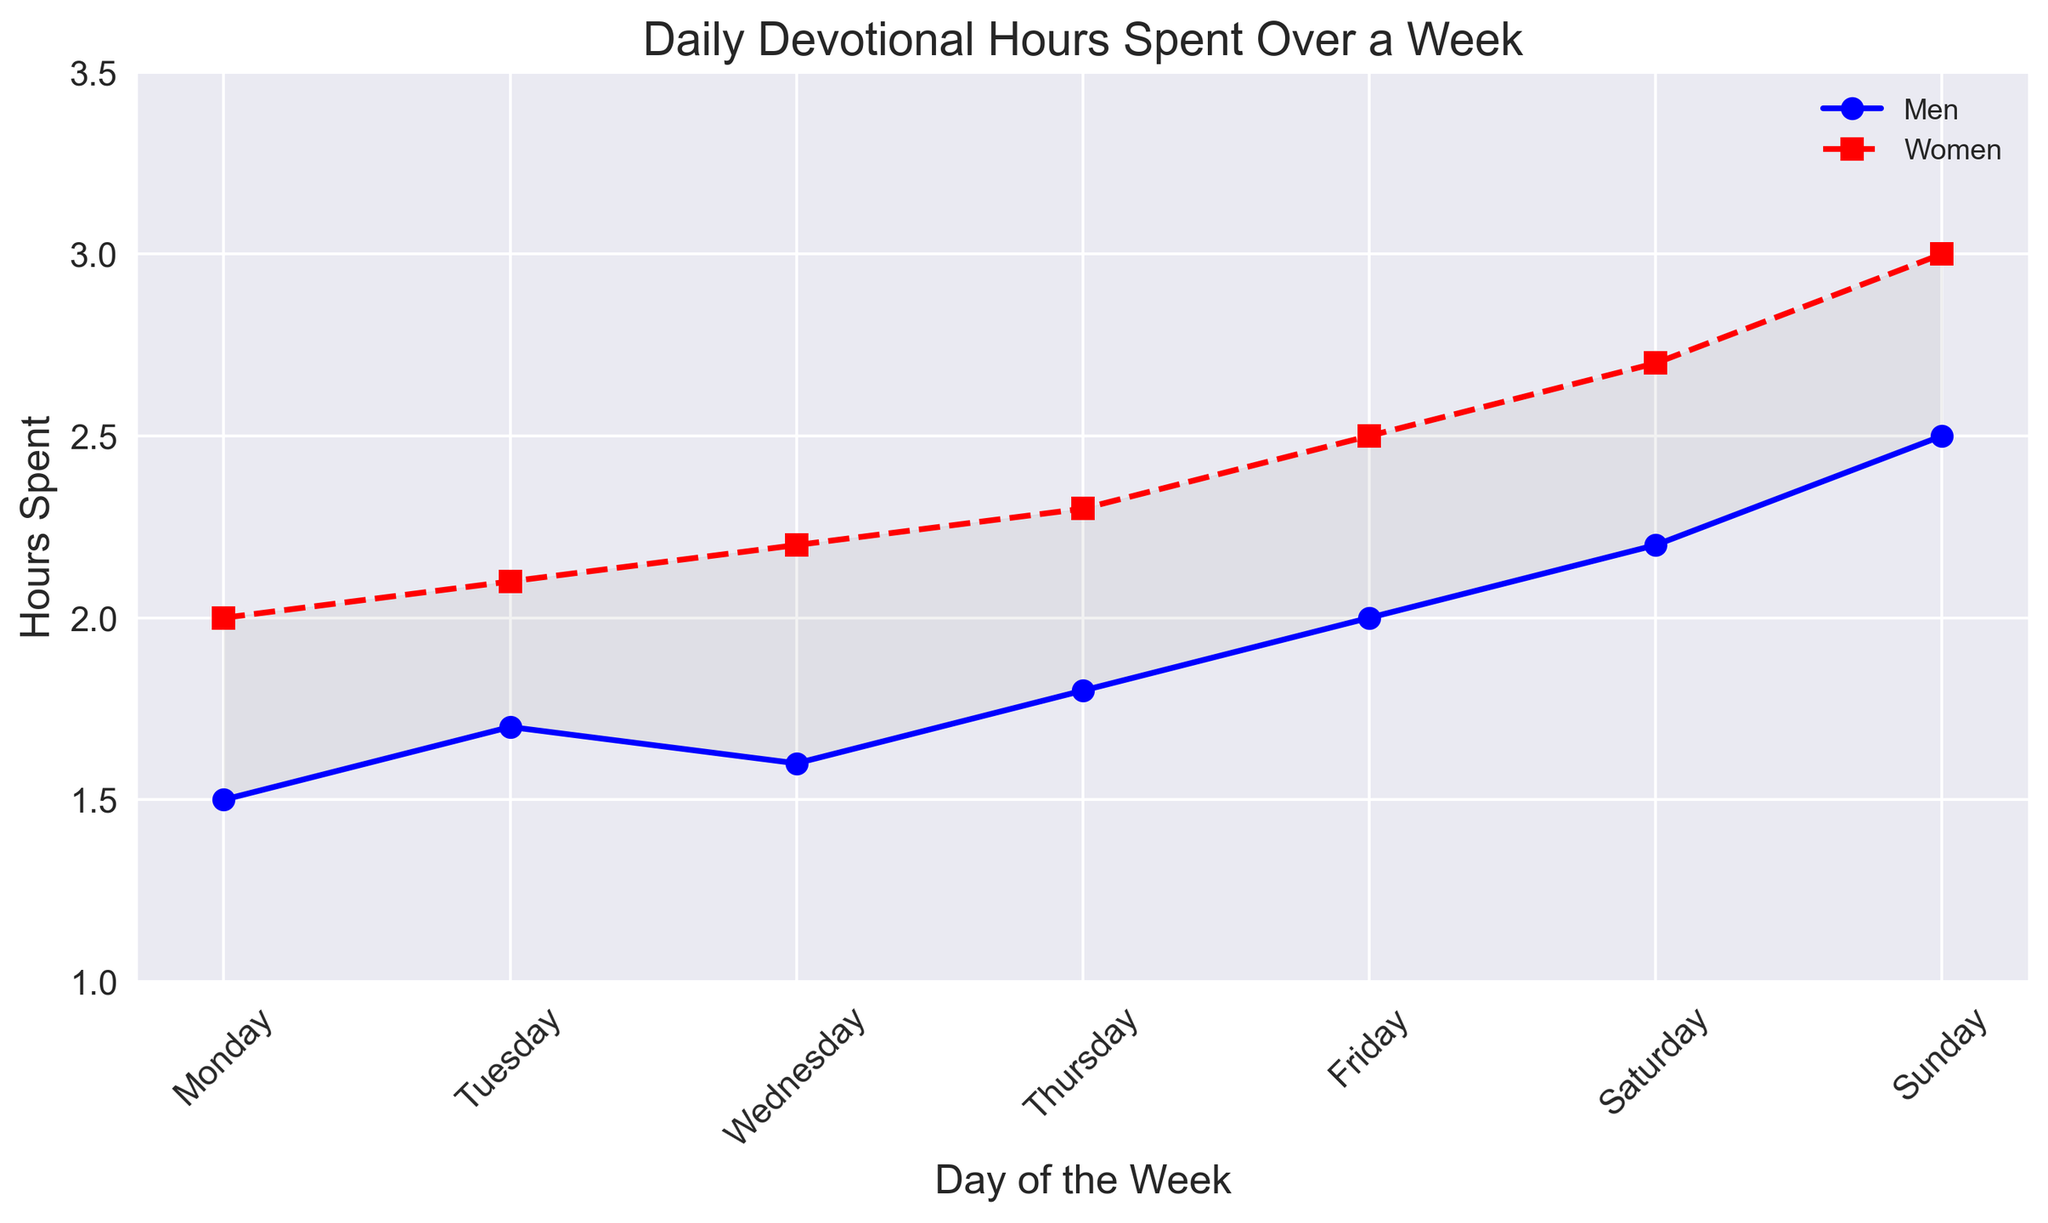What is the difference in devotional hours between men and women on Tuesday? To find the difference, subtract the hours spent by men from the hours spent by women on Tuesday. Women spent 2.1 hours and men spent 1.7 hours, so the difference is 2.1 - 1.7 = 0.4 hours.
Answer: 0.4 hours Which day did men spend the most time on their devotions? Look at the plot to find the maximum point on the line representing men's devotional hours. The highest value on the 'Men' line is on Sunday with 2.5 hours.
Answer: Sunday On which day is the gap between men’s and women’s devotional hours the largest? The gap between men’s and women’s devotional hours can be seen from the filled area between the two lines. The largest gap, visually, is on Friday where the difference is the highest. Women spent 2.5 hours while men spent 2.0 hours, a difference of 0.5 hours.
Answer: Friday What is the average devotional time spent by women over the week? Add up the hours women spent each day and then divide by the number of days (7). The total is (2.0 + 2.1 + 2.2 + 2.3 + 2.5 + 2.7 + 3.0) = 16.8 hours. The average is 16.8 / 7 = 2.4 hours.
Answer: 2.4 hours By how much did the devotional hours increase for men from Monday to Sunday? Subtract the hours spent on Monday from the hours spent on Sunday. On Monday, men spent 1.5 hours, and on Sunday, they spent 2.5 hours. The increase is 2.5 - 1.5 = 1.0 hour.
Answer: 1.0 hour Which gender spent more time on devotional activities on Saturday, and by how much? Compare the hours plotted for men and women on Saturday. Women spent 2.7 hours, and men spent 2.2 hours. Women spent 2.7 - 2.2 = 0.5 hours more.
Answer: Women, 0.5 hours Are there any days where men spent more time than women on their devotions? Look for any points where the line representing men is above the line for women. On inspection, no points are showing men spending more hours than women on any given day.
Answer: No What is the total devotional time spent by men over the week? Add up the hours men spent each day: (1.5 + 1.7 + 1.6 + 1.8 + 2.0 + 2.2 + 2.5) = 13.3 hours.
Answer: 13.3 hours How does the trend in devotional hours differ between men and women over the days? Visually inspect the plot lines. Both men and women show an increasing trend in devotional hours over the week; however, the increase is more pronounced in women, as their hours consistently rise more steeply compared to men.
Answer: Women's devotion hours increase more steeply What is the difference between the average devotional hours spent by men and women? First, calculate the average hours spent by both genders. For men: (1.5 + 1.7 + 1.6 + 1.8 + 2.0 + 2.2 + 2.5) / 7 = 13.3 / 7 ≈ 1.9 hours. For women: (2.0 + 2.1 + 2.2 + 2.3 + 2.5 + 2.7 + 3.0) / 7 = 16.8 / 7 = 2.4 hours. The difference is 2.4 - 1.9 = 0.5 hours.
Answer: 0.5 hours 